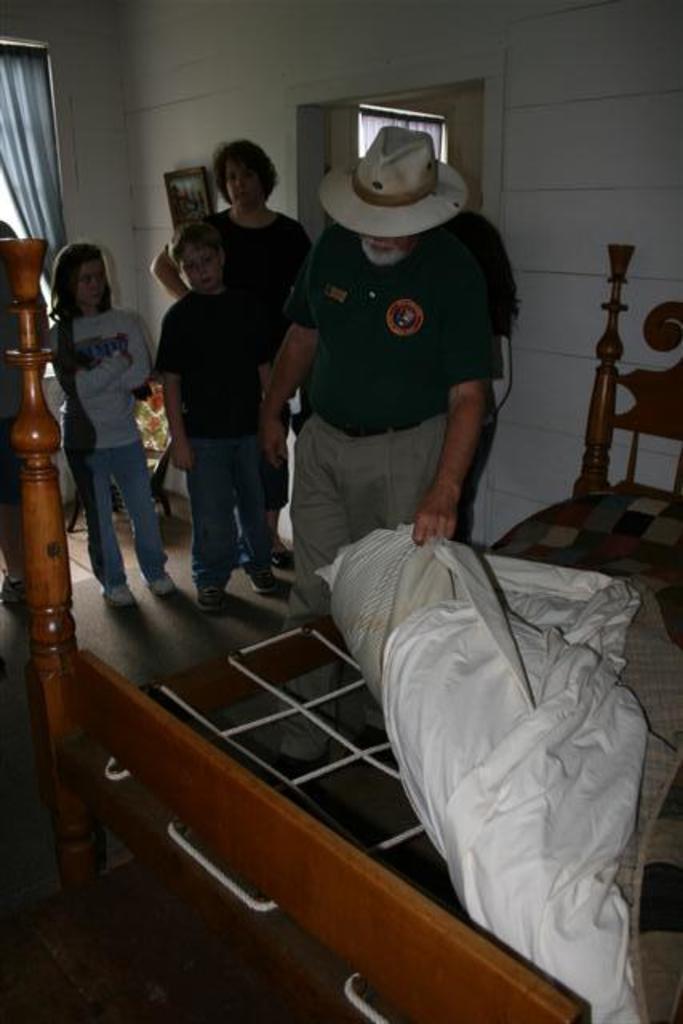In one or two sentences, can you explain what this image depicts? In this picture we can few persons standing and observing this bed. Here we can see a man wearing a hat in cream colour and holding a bed in his hand. On the background we can see curtain and wall. This is a floor. 